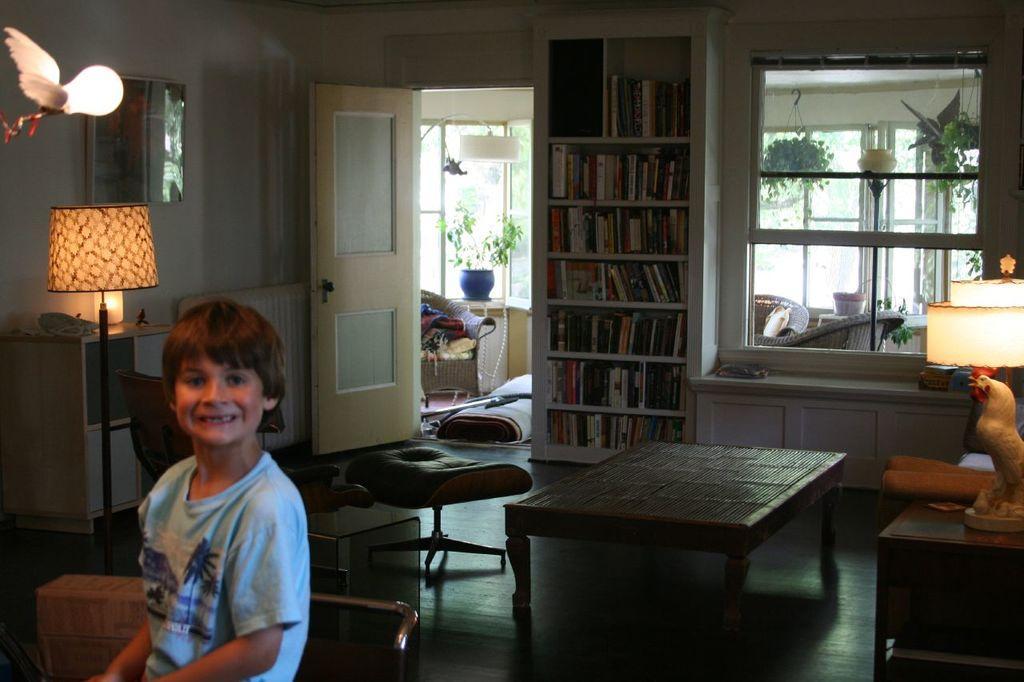Can you describe this image briefly? This is a room at the left side of the image there is a kid wearing blue color T-shirt standing and at the middle of the image there is a door and books shelf and at the right side of the image there is a lamp. 